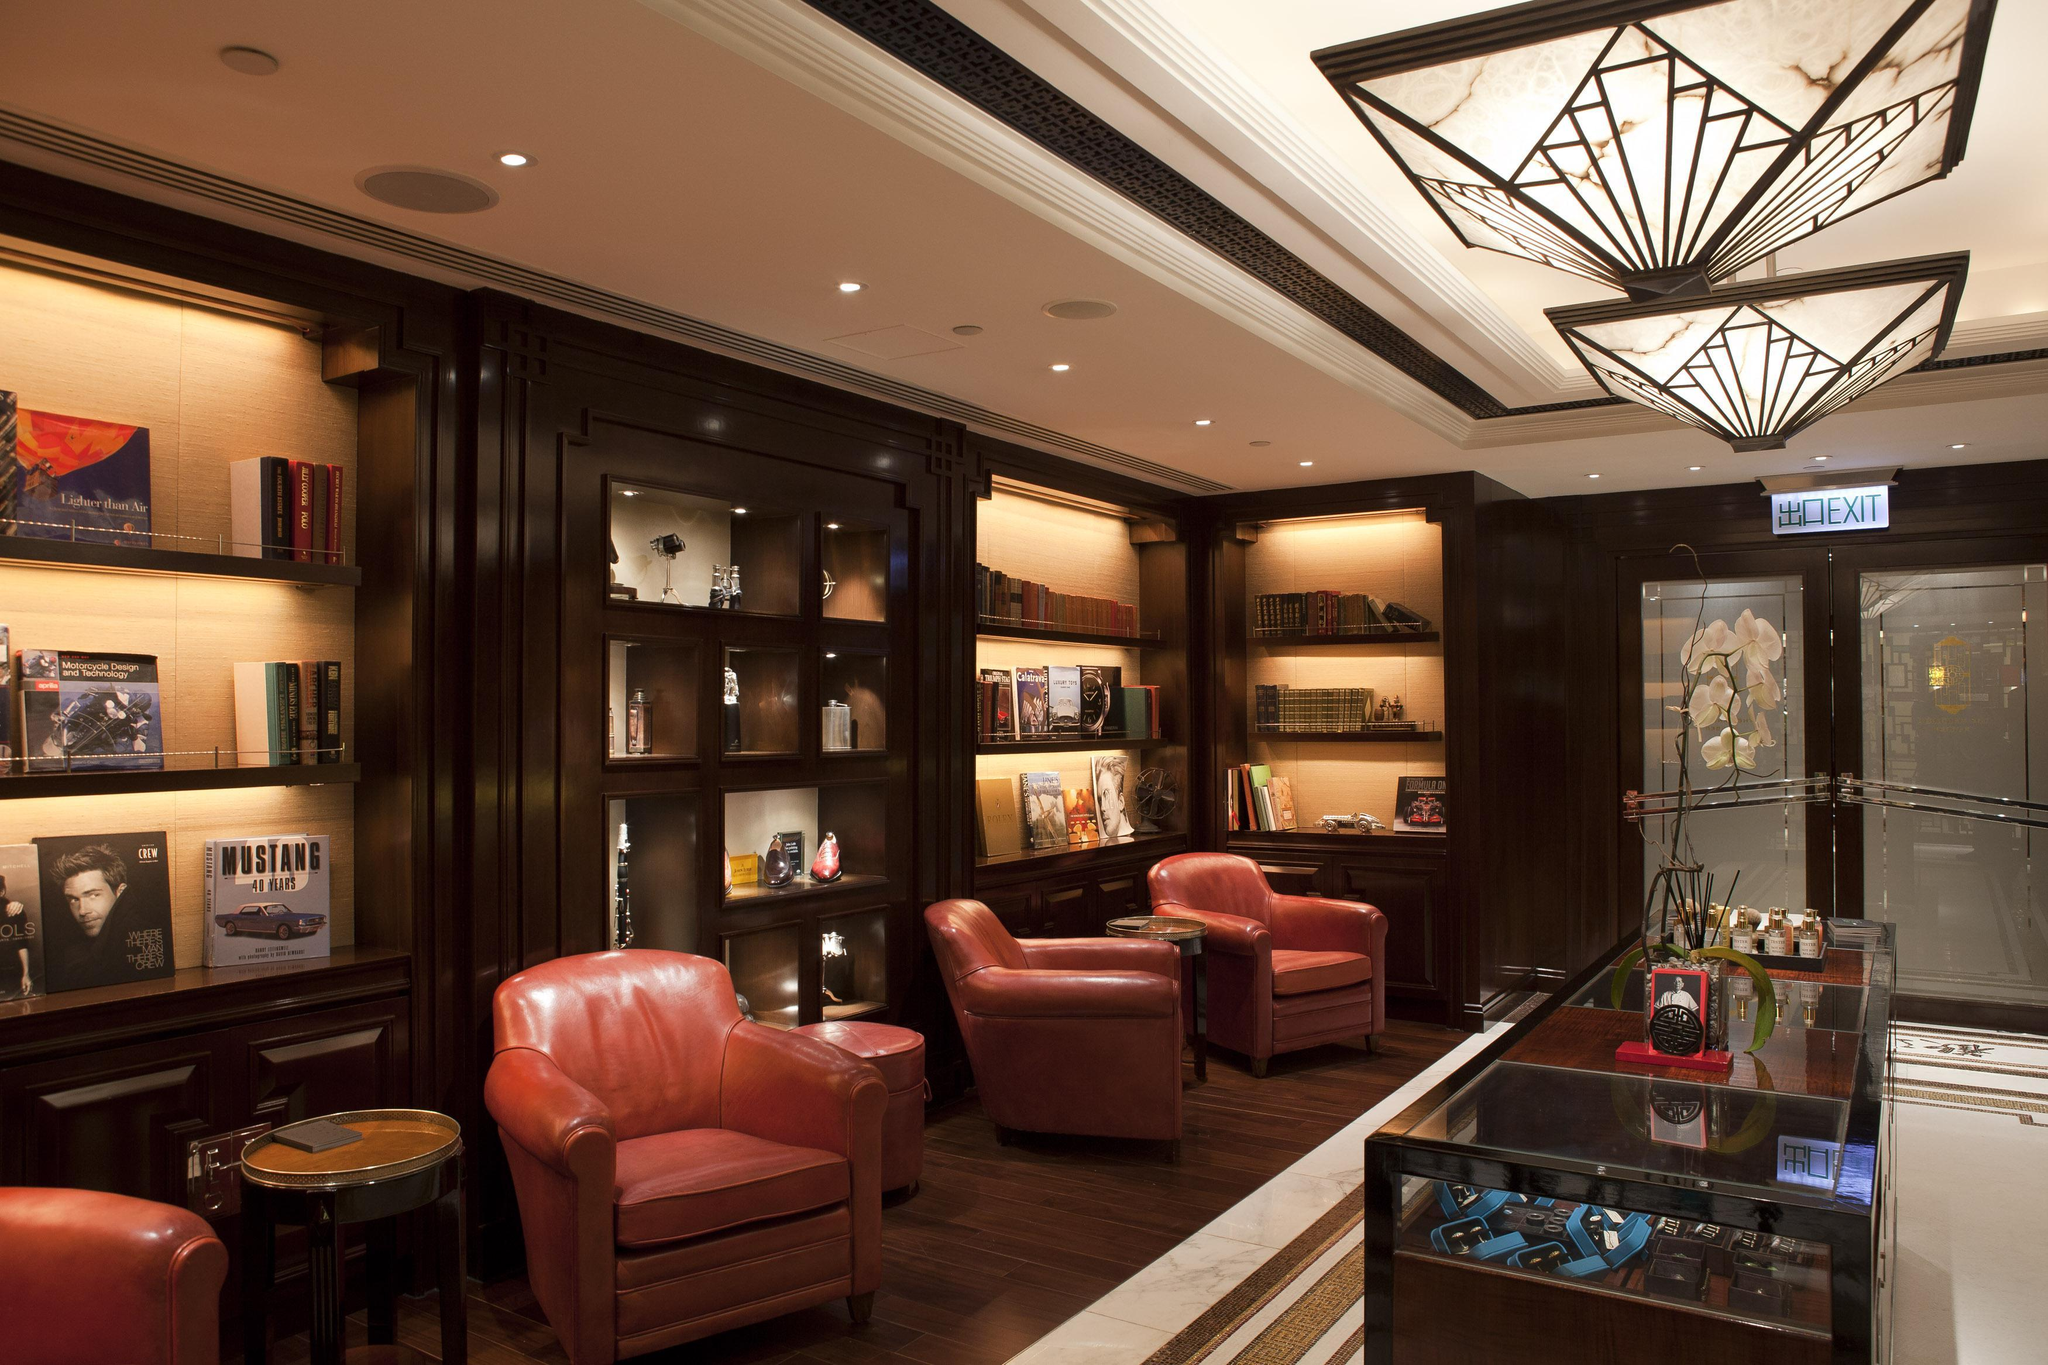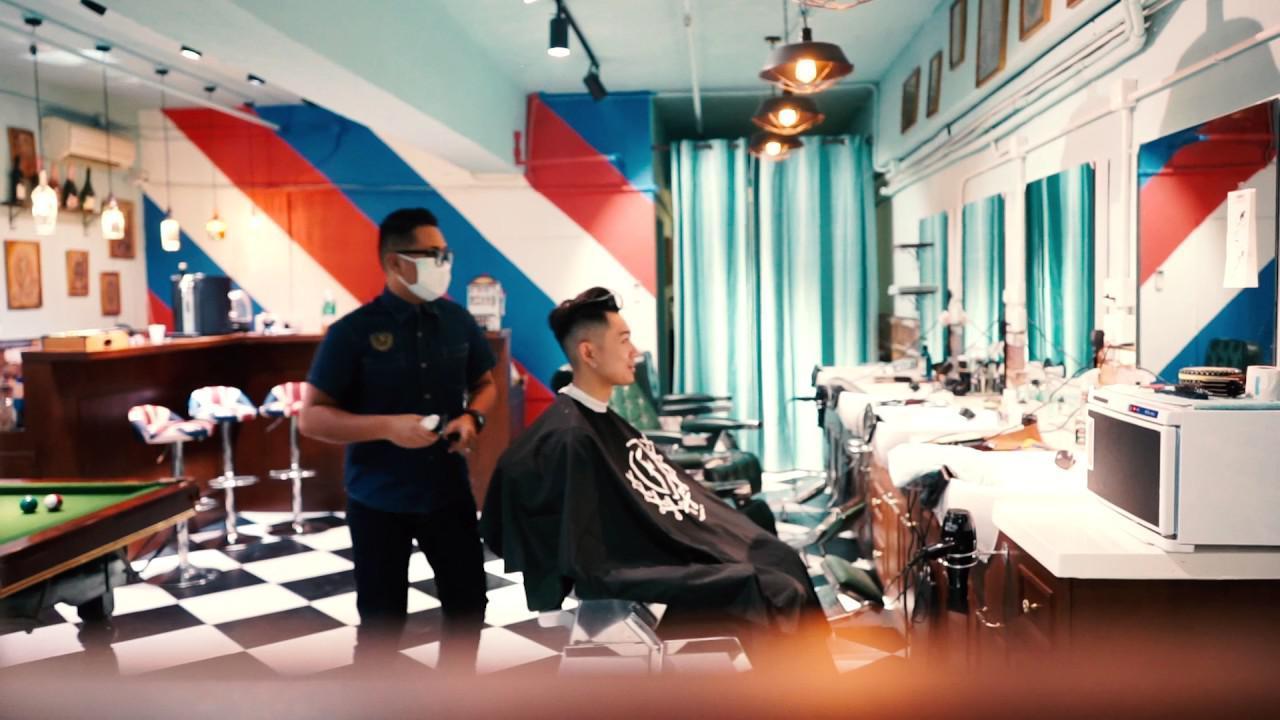The first image is the image on the left, the second image is the image on the right. For the images shown, is this caption "There are at least two bright red chairs." true? Answer yes or no. Yes. The first image is the image on the left, the second image is the image on the right. Considering the images on both sides, is "Both rooms are empty." valid? Answer yes or no. No. 